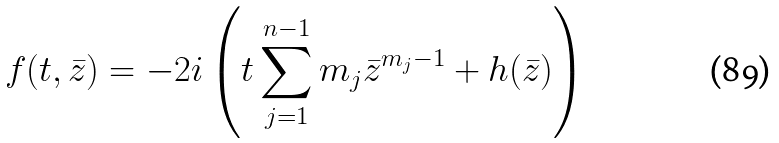Convert formula to latex. <formula><loc_0><loc_0><loc_500><loc_500>f ( t , \bar { z } ) = - 2 i \left ( t \sum _ { j = 1 } ^ { n - 1 } m _ { j } \bar { z } ^ { m _ { j } - 1 } + h ( \bar { z } ) \right )</formula> 